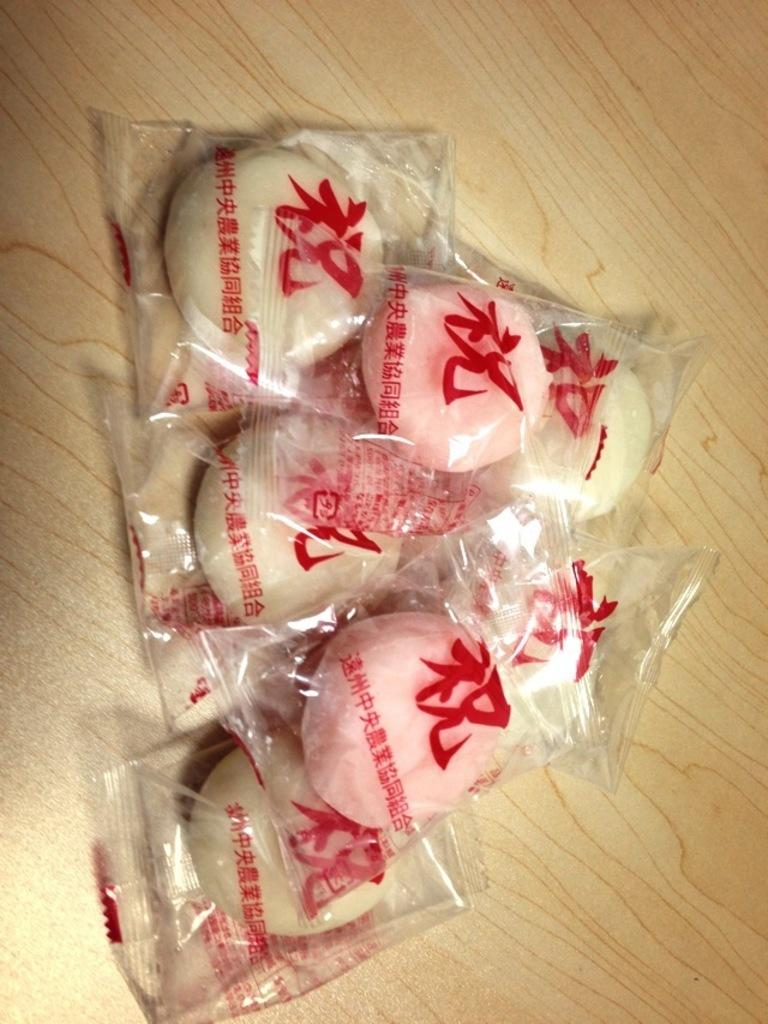What colors are the objects in the image? The objects in the image have cream and pink colors. How are the objects protected in the image? The objects are covered in a plastic cover. What is the surface on which the objects are placed? The objects are on a brown surface. How does the rainstorm affect the objects in the image? There is no rainstorm present in the image, so it cannot affect the objects. 